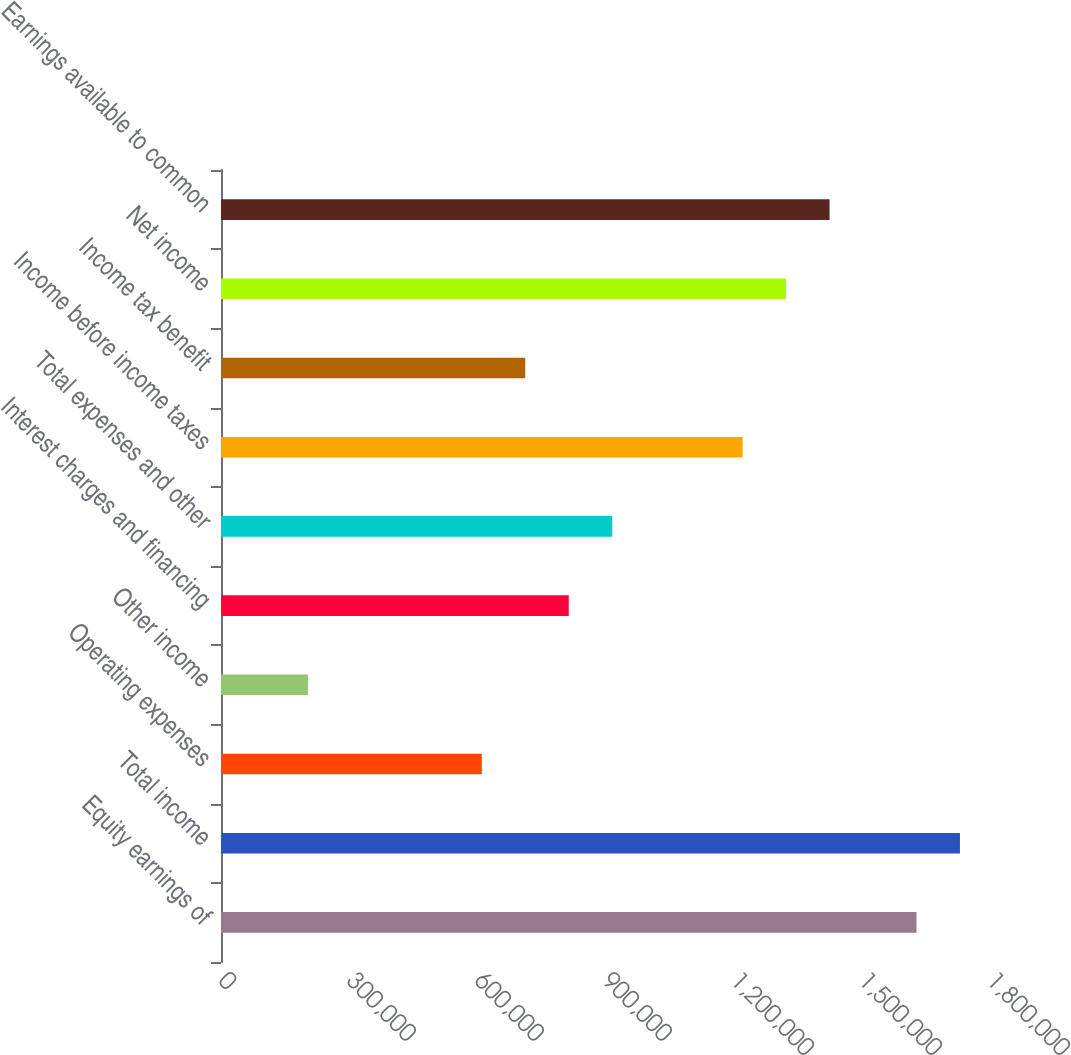Convert chart to OTSL. <chart><loc_0><loc_0><loc_500><loc_500><bar_chart><fcel>Equity earnings of<fcel>Total income<fcel>Operating expenses<fcel>Other income<fcel>Interest charges and financing<fcel>Total expenses and other<fcel>Income before income taxes<fcel>Income tax benefit<fcel>Net income<fcel>Earnings available to common<nl><fcel>1.63005e+06<fcel>1.73193e+06<fcel>611270<fcel>203757<fcel>815027<fcel>916905<fcel>1.22254e+06<fcel>713148<fcel>1.32442e+06<fcel>1.4263e+06<nl></chart> 